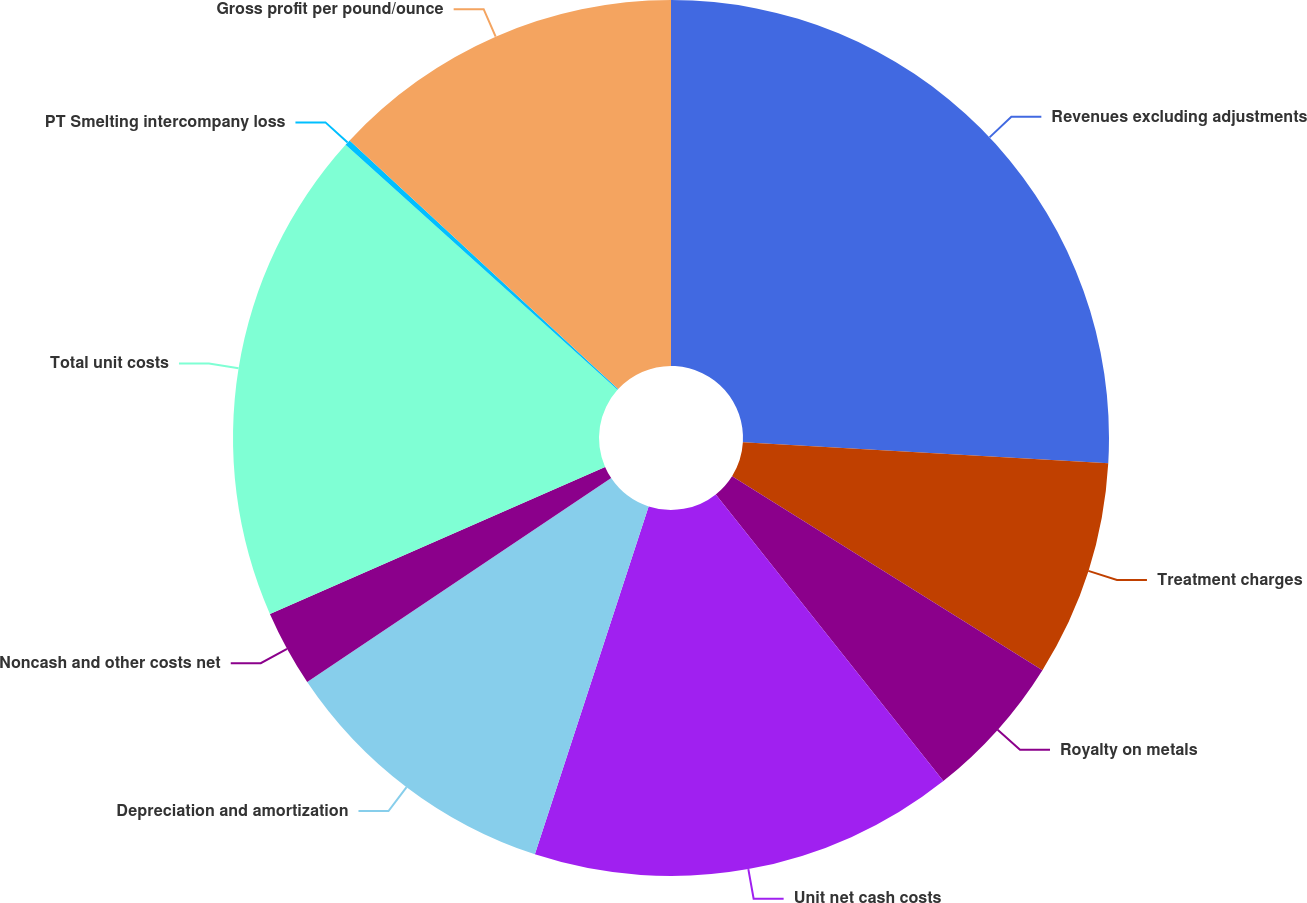Convert chart to OTSL. <chart><loc_0><loc_0><loc_500><loc_500><pie_chart><fcel>Revenues excluding adjustments<fcel>Treatment charges<fcel>Royalty on metals<fcel>Unit net cash costs<fcel>Depreciation and amortization<fcel>Noncash and other costs net<fcel>Total unit costs<fcel>PT Smelting intercompany loss<fcel>Gross profit per pound/ounce<nl><fcel>25.92%<fcel>7.97%<fcel>5.43%<fcel>15.71%<fcel>10.57%<fcel>2.82%<fcel>18.25%<fcel>0.22%<fcel>13.11%<nl></chart> 